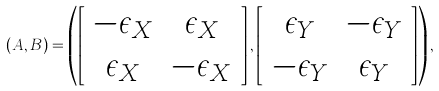Convert formula to latex. <formula><loc_0><loc_0><loc_500><loc_500>( A , B ) = \left ( \left [ \begin{array} { c c } - \epsilon _ { X } & \epsilon _ { X } \\ \epsilon _ { X } & - \epsilon _ { X } \\ \end{array} \right ] , \left [ \begin{array} { c c } \epsilon _ { Y } & - \epsilon _ { Y } \\ - \epsilon _ { Y } & \epsilon _ { Y } \\ \end{array} \right ] \right ) ,</formula> 